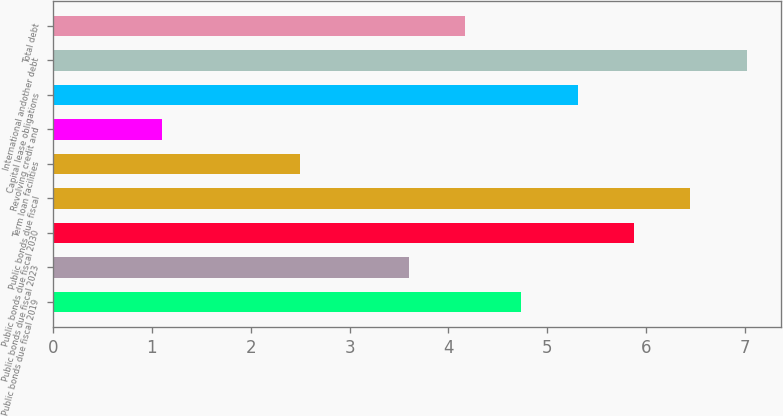<chart> <loc_0><loc_0><loc_500><loc_500><bar_chart><fcel>Public bonds due fiscal 2019<fcel>Public bonds due fiscal 2023<fcel>Public bonds due fiscal 2030<fcel>Public bonds due fiscal<fcel>Term loan facilities<fcel>Revolving credit and<fcel>Capital lease obligations<fcel>International andother debt<fcel>Total debt<nl><fcel>4.74<fcel>3.6<fcel>5.88<fcel>6.45<fcel>2.5<fcel>1.1<fcel>5.31<fcel>7.02<fcel>4.17<nl></chart> 